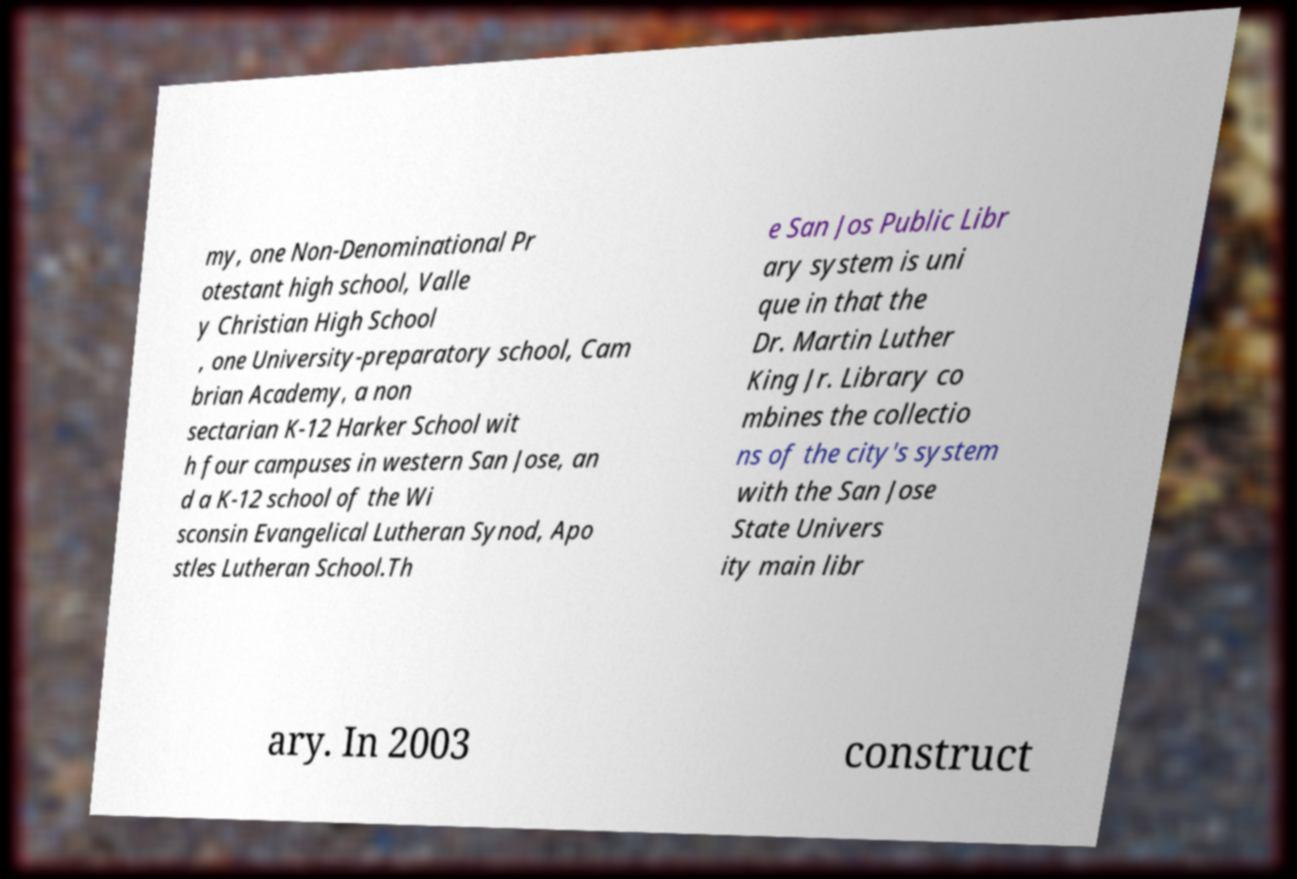Could you assist in decoding the text presented in this image and type it out clearly? my, one Non-Denominational Pr otestant high school, Valle y Christian High School , one University-preparatory school, Cam brian Academy, a non sectarian K-12 Harker School wit h four campuses in western San Jose, an d a K-12 school of the Wi sconsin Evangelical Lutheran Synod, Apo stles Lutheran School.Th e San Jos Public Libr ary system is uni que in that the Dr. Martin Luther King Jr. Library co mbines the collectio ns of the city's system with the San Jose State Univers ity main libr ary. In 2003 construct 